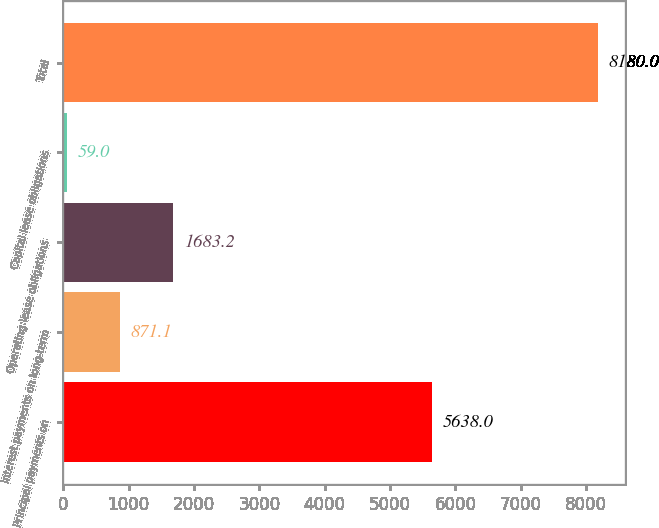<chart> <loc_0><loc_0><loc_500><loc_500><bar_chart><fcel>Principal payments on<fcel>Interest payments on long-term<fcel>Operating lease obligations<fcel>Capital lease obligations<fcel>Total<nl><fcel>5638<fcel>871.1<fcel>1683.2<fcel>59<fcel>8180<nl></chart> 